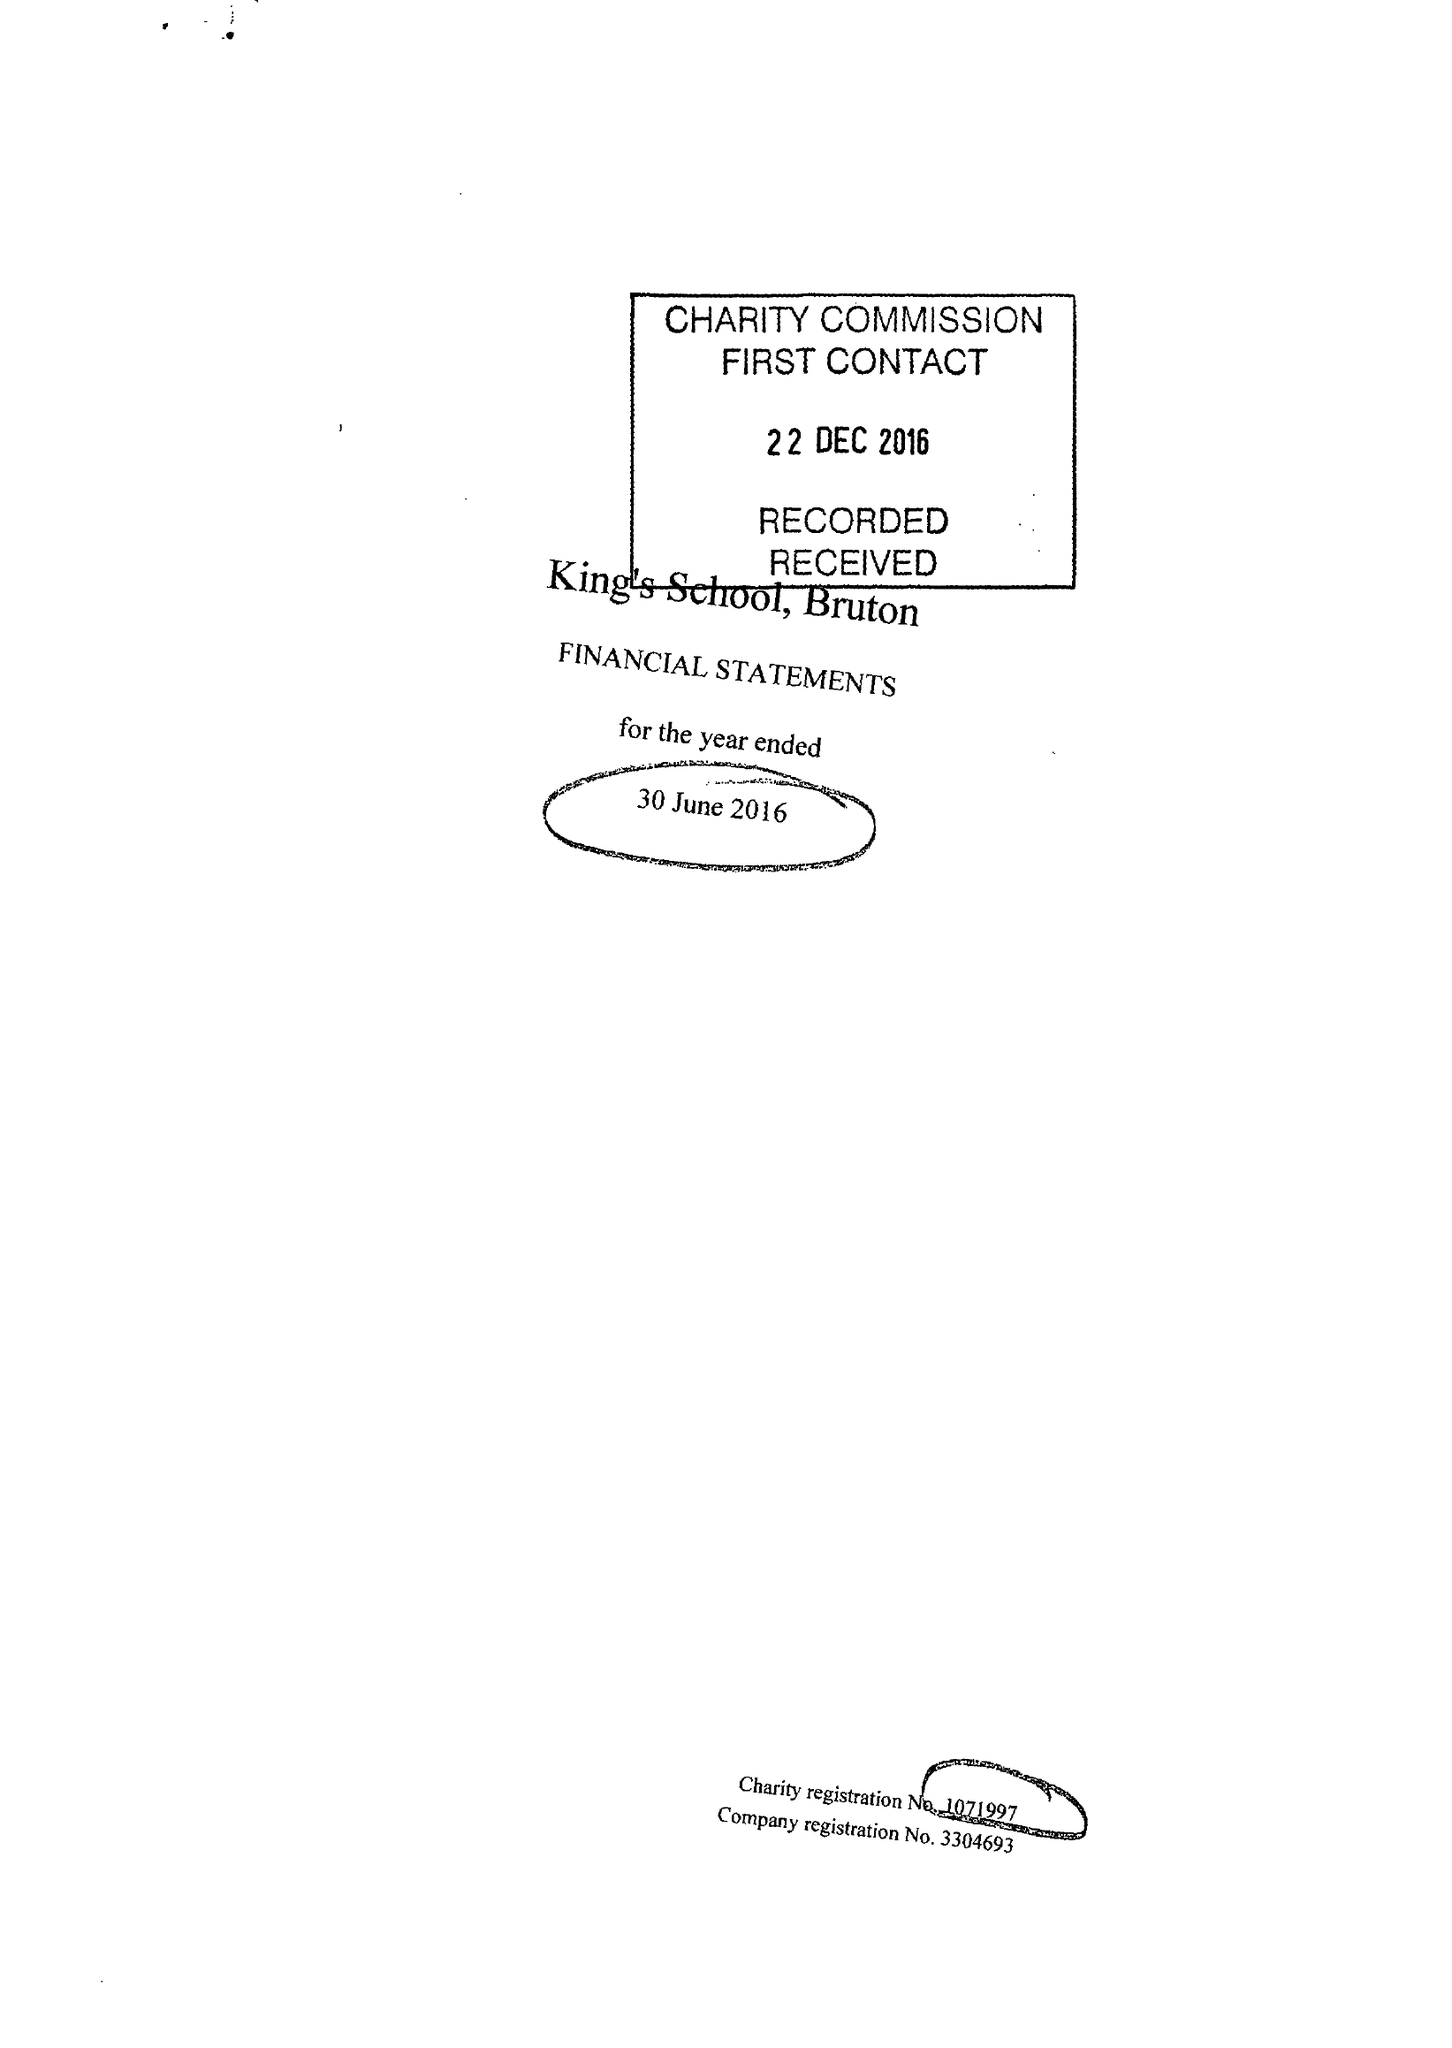What is the value for the spending_annually_in_british_pounds?
Answer the question using a single word or phrase. 13195423.00 